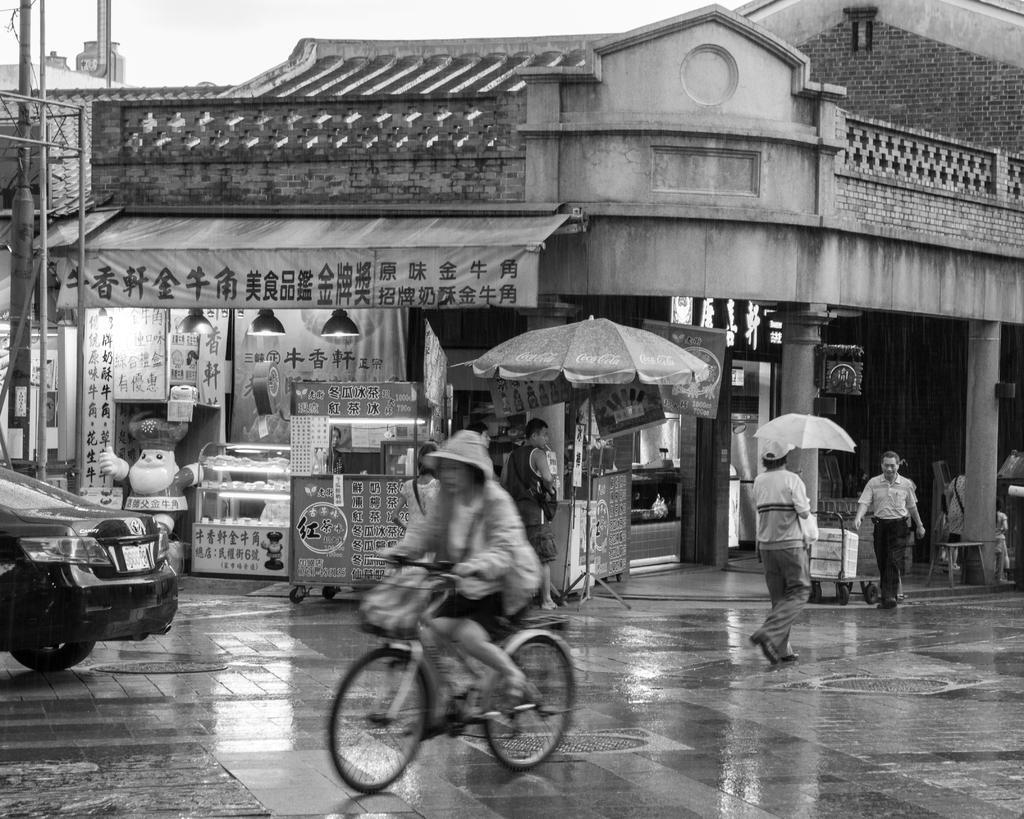Describe this image in one or two sentences. It is a black and white image there is store and in front of the store there is a vehicle and a cycle are moving and beside the store two people are walking and it looks like it is raining, one of the person is carrying an umbrella with him. 